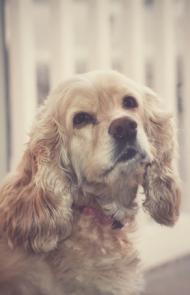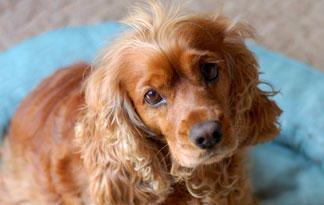The first image is the image on the left, the second image is the image on the right. Considering the images on both sides, is "The left image shows a spaniel with its body in profile." valid? Answer yes or no. No. 